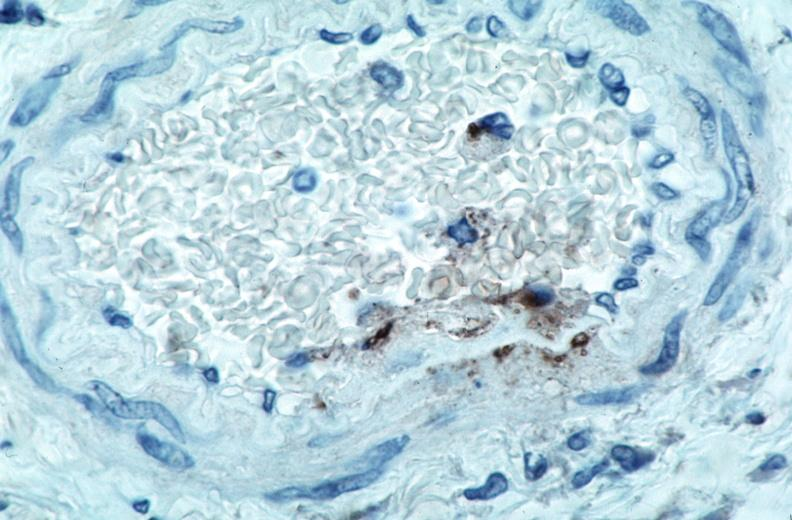s rocky mountain spotted fever, immunoperoxidase staining vessels for rickettsia rickettsii?
Answer the question using a single word or phrase. Yes 